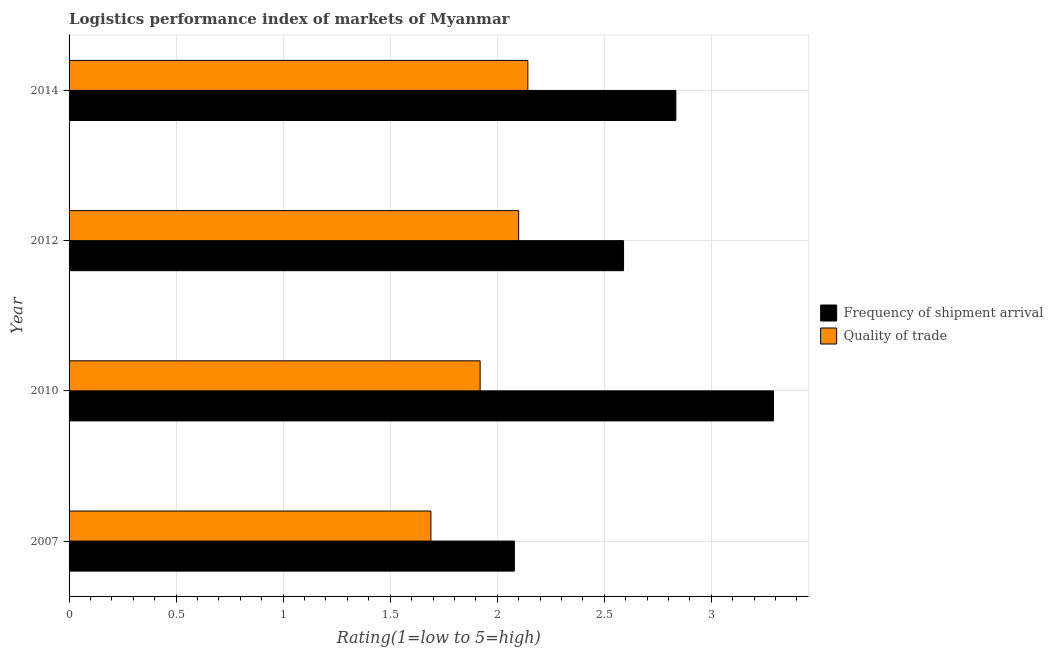Are the number of bars per tick equal to the number of legend labels?
Your answer should be very brief. Yes. What is the label of the 4th group of bars from the top?
Ensure brevity in your answer.  2007. In how many cases, is the number of bars for a given year not equal to the number of legend labels?
Your answer should be compact. 0. What is the lpi of frequency of shipment arrival in 2010?
Give a very brief answer. 3.29. Across all years, what is the maximum lpi quality of trade?
Your response must be concise. 2.14. Across all years, what is the minimum lpi of frequency of shipment arrival?
Your answer should be compact. 2.08. In which year was the lpi of frequency of shipment arrival maximum?
Offer a very short reply. 2010. In which year was the lpi quality of trade minimum?
Provide a short and direct response. 2007. What is the total lpi of frequency of shipment arrival in the graph?
Ensure brevity in your answer.  10.79. What is the difference between the lpi of frequency of shipment arrival in 2010 and the lpi quality of trade in 2012?
Ensure brevity in your answer.  1.19. What is the average lpi quality of trade per year?
Your answer should be compact. 1.96. In the year 2010, what is the difference between the lpi of frequency of shipment arrival and lpi quality of trade?
Give a very brief answer. 1.37. What is the ratio of the lpi of frequency of shipment arrival in 2007 to that in 2010?
Your answer should be compact. 0.63. Is the lpi quality of trade in 2010 less than that in 2014?
Provide a short and direct response. Yes. What is the difference between the highest and the second highest lpi of frequency of shipment arrival?
Give a very brief answer. 0.46. What is the difference between the highest and the lowest lpi quality of trade?
Keep it short and to the point. 0.45. In how many years, is the lpi of frequency of shipment arrival greater than the average lpi of frequency of shipment arrival taken over all years?
Make the answer very short. 2. Is the sum of the lpi of frequency of shipment arrival in 2007 and 2012 greater than the maximum lpi quality of trade across all years?
Offer a very short reply. Yes. What does the 1st bar from the top in 2014 represents?
Give a very brief answer. Quality of trade. What does the 1st bar from the bottom in 2010 represents?
Your answer should be compact. Frequency of shipment arrival. Are all the bars in the graph horizontal?
Provide a short and direct response. Yes. How many years are there in the graph?
Make the answer very short. 4. What is the difference between two consecutive major ticks on the X-axis?
Offer a very short reply. 0.5. Are the values on the major ticks of X-axis written in scientific E-notation?
Make the answer very short. No. Does the graph contain any zero values?
Give a very brief answer. No. Does the graph contain grids?
Keep it short and to the point. Yes. Where does the legend appear in the graph?
Your answer should be very brief. Center right. How are the legend labels stacked?
Ensure brevity in your answer.  Vertical. What is the title of the graph?
Offer a terse response. Logistics performance index of markets of Myanmar. What is the label or title of the X-axis?
Keep it short and to the point. Rating(1=low to 5=high). What is the label or title of the Y-axis?
Provide a short and direct response. Year. What is the Rating(1=low to 5=high) of Frequency of shipment arrival in 2007?
Your answer should be very brief. 2.08. What is the Rating(1=low to 5=high) of Quality of trade in 2007?
Offer a terse response. 1.69. What is the Rating(1=low to 5=high) in Frequency of shipment arrival in 2010?
Provide a short and direct response. 3.29. What is the Rating(1=low to 5=high) in Quality of trade in 2010?
Your response must be concise. 1.92. What is the Rating(1=low to 5=high) of Frequency of shipment arrival in 2012?
Make the answer very short. 2.59. What is the Rating(1=low to 5=high) in Quality of trade in 2012?
Provide a succinct answer. 2.1. What is the Rating(1=low to 5=high) of Frequency of shipment arrival in 2014?
Offer a terse response. 2.83. What is the Rating(1=low to 5=high) of Quality of trade in 2014?
Keep it short and to the point. 2.14. Across all years, what is the maximum Rating(1=low to 5=high) in Frequency of shipment arrival?
Offer a very short reply. 3.29. Across all years, what is the maximum Rating(1=low to 5=high) in Quality of trade?
Offer a terse response. 2.14. Across all years, what is the minimum Rating(1=low to 5=high) in Frequency of shipment arrival?
Your response must be concise. 2.08. Across all years, what is the minimum Rating(1=low to 5=high) in Quality of trade?
Provide a succinct answer. 1.69. What is the total Rating(1=low to 5=high) of Frequency of shipment arrival in the graph?
Ensure brevity in your answer.  10.79. What is the total Rating(1=low to 5=high) in Quality of trade in the graph?
Your answer should be compact. 7.85. What is the difference between the Rating(1=low to 5=high) in Frequency of shipment arrival in 2007 and that in 2010?
Your response must be concise. -1.21. What is the difference between the Rating(1=low to 5=high) of Quality of trade in 2007 and that in 2010?
Offer a terse response. -0.23. What is the difference between the Rating(1=low to 5=high) of Frequency of shipment arrival in 2007 and that in 2012?
Your response must be concise. -0.51. What is the difference between the Rating(1=low to 5=high) in Quality of trade in 2007 and that in 2012?
Offer a terse response. -0.41. What is the difference between the Rating(1=low to 5=high) of Frequency of shipment arrival in 2007 and that in 2014?
Your answer should be very brief. -0.75. What is the difference between the Rating(1=low to 5=high) in Quality of trade in 2007 and that in 2014?
Keep it short and to the point. -0.45. What is the difference between the Rating(1=low to 5=high) of Quality of trade in 2010 and that in 2012?
Ensure brevity in your answer.  -0.18. What is the difference between the Rating(1=low to 5=high) in Frequency of shipment arrival in 2010 and that in 2014?
Ensure brevity in your answer.  0.46. What is the difference between the Rating(1=low to 5=high) in Quality of trade in 2010 and that in 2014?
Your response must be concise. -0.22. What is the difference between the Rating(1=low to 5=high) in Frequency of shipment arrival in 2012 and that in 2014?
Keep it short and to the point. -0.24. What is the difference between the Rating(1=low to 5=high) of Quality of trade in 2012 and that in 2014?
Offer a terse response. -0.04. What is the difference between the Rating(1=low to 5=high) in Frequency of shipment arrival in 2007 and the Rating(1=low to 5=high) in Quality of trade in 2010?
Provide a succinct answer. 0.16. What is the difference between the Rating(1=low to 5=high) in Frequency of shipment arrival in 2007 and the Rating(1=low to 5=high) in Quality of trade in 2012?
Ensure brevity in your answer.  -0.02. What is the difference between the Rating(1=low to 5=high) of Frequency of shipment arrival in 2007 and the Rating(1=low to 5=high) of Quality of trade in 2014?
Offer a very short reply. -0.06. What is the difference between the Rating(1=low to 5=high) of Frequency of shipment arrival in 2010 and the Rating(1=low to 5=high) of Quality of trade in 2012?
Your answer should be very brief. 1.19. What is the difference between the Rating(1=low to 5=high) in Frequency of shipment arrival in 2010 and the Rating(1=low to 5=high) in Quality of trade in 2014?
Provide a succinct answer. 1.15. What is the difference between the Rating(1=low to 5=high) in Frequency of shipment arrival in 2012 and the Rating(1=low to 5=high) in Quality of trade in 2014?
Your answer should be compact. 0.45. What is the average Rating(1=low to 5=high) of Frequency of shipment arrival per year?
Provide a short and direct response. 2.7. What is the average Rating(1=low to 5=high) of Quality of trade per year?
Your answer should be very brief. 1.96. In the year 2007, what is the difference between the Rating(1=low to 5=high) in Frequency of shipment arrival and Rating(1=low to 5=high) in Quality of trade?
Your response must be concise. 0.39. In the year 2010, what is the difference between the Rating(1=low to 5=high) in Frequency of shipment arrival and Rating(1=low to 5=high) in Quality of trade?
Offer a very short reply. 1.37. In the year 2012, what is the difference between the Rating(1=low to 5=high) of Frequency of shipment arrival and Rating(1=low to 5=high) of Quality of trade?
Your answer should be very brief. 0.49. In the year 2014, what is the difference between the Rating(1=low to 5=high) of Frequency of shipment arrival and Rating(1=low to 5=high) of Quality of trade?
Your answer should be compact. 0.69. What is the ratio of the Rating(1=low to 5=high) in Frequency of shipment arrival in 2007 to that in 2010?
Make the answer very short. 0.63. What is the ratio of the Rating(1=low to 5=high) of Quality of trade in 2007 to that in 2010?
Offer a terse response. 0.88. What is the ratio of the Rating(1=low to 5=high) in Frequency of shipment arrival in 2007 to that in 2012?
Your answer should be very brief. 0.8. What is the ratio of the Rating(1=low to 5=high) of Quality of trade in 2007 to that in 2012?
Keep it short and to the point. 0.8. What is the ratio of the Rating(1=low to 5=high) of Frequency of shipment arrival in 2007 to that in 2014?
Provide a short and direct response. 0.73. What is the ratio of the Rating(1=low to 5=high) of Quality of trade in 2007 to that in 2014?
Your response must be concise. 0.79. What is the ratio of the Rating(1=low to 5=high) of Frequency of shipment arrival in 2010 to that in 2012?
Provide a short and direct response. 1.27. What is the ratio of the Rating(1=low to 5=high) of Quality of trade in 2010 to that in 2012?
Provide a succinct answer. 0.91. What is the ratio of the Rating(1=low to 5=high) in Frequency of shipment arrival in 2010 to that in 2014?
Provide a short and direct response. 1.16. What is the ratio of the Rating(1=low to 5=high) of Quality of trade in 2010 to that in 2014?
Offer a terse response. 0.9. What is the ratio of the Rating(1=low to 5=high) of Frequency of shipment arrival in 2012 to that in 2014?
Offer a very short reply. 0.91. What is the difference between the highest and the second highest Rating(1=low to 5=high) in Frequency of shipment arrival?
Offer a very short reply. 0.46. What is the difference between the highest and the second highest Rating(1=low to 5=high) in Quality of trade?
Give a very brief answer. 0.04. What is the difference between the highest and the lowest Rating(1=low to 5=high) in Frequency of shipment arrival?
Your answer should be compact. 1.21. What is the difference between the highest and the lowest Rating(1=low to 5=high) in Quality of trade?
Ensure brevity in your answer.  0.45. 